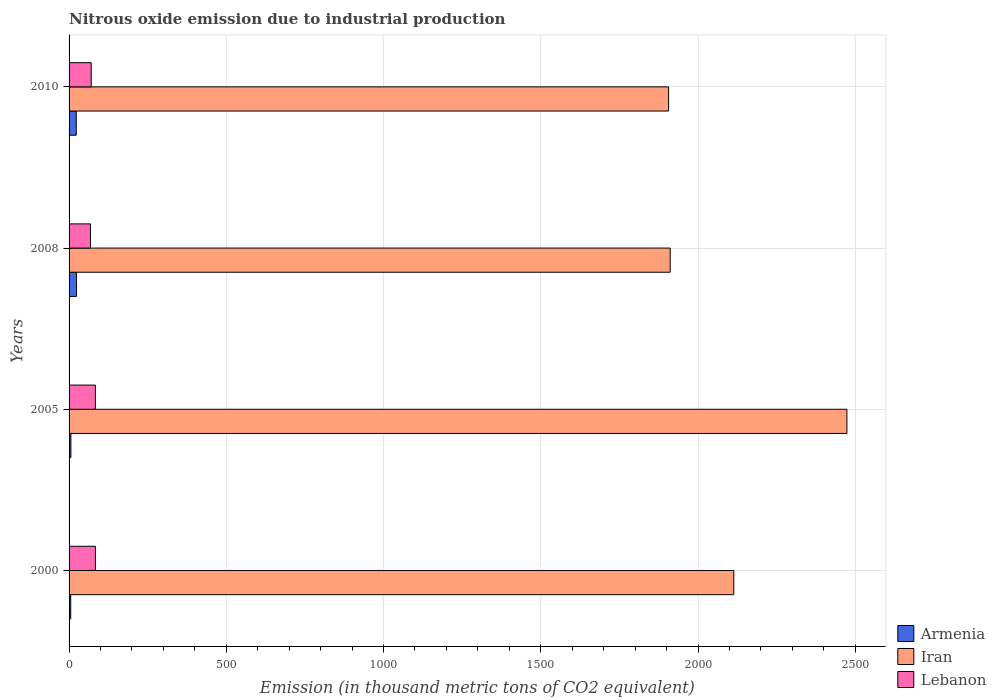Are the number of bars on each tick of the Y-axis equal?
Give a very brief answer. Yes. How many bars are there on the 1st tick from the bottom?
Offer a terse response. 3. What is the amount of nitrous oxide emitted in Armenia in 2010?
Keep it short and to the point. 22.8. Across all years, what is the maximum amount of nitrous oxide emitted in Iran?
Give a very brief answer. 2473.5. In which year was the amount of nitrous oxide emitted in Armenia maximum?
Ensure brevity in your answer.  2008. In which year was the amount of nitrous oxide emitted in Armenia minimum?
Offer a terse response. 2000. What is the total amount of nitrous oxide emitted in Armenia in the graph?
Provide a succinct answer. 57.5. What is the difference between the amount of nitrous oxide emitted in Armenia in 2000 and that in 2010?
Your answer should be very brief. -17.6. What is the difference between the amount of nitrous oxide emitted in Lebanon in 2010 and the amount of nitrous oxide emitted in Armenia in 2005?
Your answer should be very brief. 64.6. What is the average amount of nitrous oxide emitted in Lebanon per year?
Your answer should be very brief. 76.47. In the year 2000, what is the difference between the amount of nitrous oxide emitted in Armenia and amount of nitrous oxide emitted in Lebanon?
Your response must be concise. -78.6. What is the ratio of the amount of nitrous oxide emitted in Lebanon in 2000 to that in 2008?
Your answer should be compact. 1.23. Is the difference between the amount of nitrous oxide emitted in Armenia in 2005 and 2010 greater than the difference between the amount of nitrous oxide emitted in Lebanon in 2005 and 2010?
Provide a short and direct response. No. What is the difference between the highest and the second highest amount of nitrous oxide emitted in Armenia?
Your answer should be compact. 0.9. What is the difference between the highest and the lowest amount of nitrous oxide emitted in Lebanon?
Ensure brevity in your answer.  15.8. In how many years, is the amount of nitrous oxide emitted in Iran greater than the average amount of nitrous oxide emitted in Iran taken over all years?
Offer a very short reply. 2. What does the 2nd bar from the top in 2005 represents?
Provide a short and direct response. Iran. What does the 3rd bar from the bottom in 2010 represents?
Offer a very short reply. Lebanon. Is it the case that in every year, the sum of the amount of nitrous oxide emitted in Lebanon and amount of nitrous oxide emitted in Iran is greater than the amount of nitrous oxide emitted in Armenia?
Offer a terse response. Yes. How many bars are there?
Offer a terse response. 12. How many years are there in the graph?
Your answer should be compact. 4. What is the difference between two consecutive major ticks on the X-axis?
Make the answer very short. 500. Are the values on the major ticks of X-axis written in scientific E-notation?
Provide a succinct answer. No. Does the graph contain any zero values?
Make the answer very short. No. How many legend labels are there?
Your answer should be very brief. 3. How are the legend labels stacked?
Your answer should be very brief. Vertical. What is the title of the graph?
Offer a very short reply. Nitrous oxide emission due to industrial production. What is the label or title of the X-axis?
Provide a short and direct response. Emission (in thousand metric tons of CO2 equivalent). What is the label or title of the Y-axis?
Make the answer very short. Years. What is the Emission (in thousand metric tons of CO2 equivalent) of Iran in 2000?
Give a very brief answer. 2113.8. What is the Emission (in thousand metric tons of CO2 equivalent) of Lebanon in 2000?
Offer a terse response. 83.8. What is the Emission (in thousand metric tons of CO2 equivalent) of Iran in 2005?
Make the answer very short. 2473.5. What is the Emission (in thousand metric tons of CO2 equivalent) of Lebanon in 2005?
Offer a very short reply. 83.7. What is the Emission (in thousand metric tons of CO2 equivalent) in Armenia in 2008?
Make the answer very short. 23.7. What is the Emission (in thousand metric tons of CO2 equivalent) in Iran in 2008?
Your answer should be compact. 1911.5. What is the Emission (in thousand metric tons of CO2 equivalent) in Lebanon in 2008?
Your answer should be compact. 68. What is the Emission (in thousand metric tons of CO2 equivalent) in Armenia in 2010?
Make the answer very short. 22.8. What is the Emission (in thousand metric tons of CO2 equivalent) of Iran in 2010?
Keep it short and to the point. 1906.5. What is the Emission (in thousand metric tons of CO2 equivalent) of Lebanon in 2010?
Your answer should be very brief. 70.4. Across all years, what is the maximum Emission (in thousand metric tons of CO2 equivalent) of Armenia?
Keep it short and to the point. 23.7. Across all years, what is the maximum Emission (in thousand metric tons of CO2 equivalent) of Iran?
Provide a short and direct response. 2473.5. Across all years, what is the maximum Emission (in thousand metric tons of CO2 equivalent) in Lebanon?
Make the answer very short. 83.8. Across all years, what is the minimum Emission (in thousand metric tons of CO2 equivalent) in Armenia?
Keep it short and to the point. 5.2. Across all years, what is the minimum Emission (in thousand metric tons of CO2 equivalent) in Iran?
Provide a short and direct response. 1906.5. Across all years, what is the minimum Emission (in thousand metric tons of CO2 equivalent) of Lebanon?
Give a very brief answer. 68. What is the total Emission (in thousand metric tons of CO2 equivalent) of Armenia in the graph?
Offer a terse response. 57.5. What is the total Emission (in thousand metric tons of CO2 equivalent) in Iran in the graph?
Your answer should be very brief. 8405.3. What is the total Emission (in thousand metric tons of CO2 equivalent) of Lebanon in the graph?
Your answer should be very brief. 305.9. What is the difference between the Emission (in thousand metric tons of CO2 equivalent) of Armenia in 2000 and that in 2005?
Provide a succinct answer. -0.6. What is the difference between the Emission (in thousand metric tons of CO2 equivalent) in Iran in 2000 and that in 2005?
Offer a terse response. -359.7. What is the difference between the Emission (in thousand metric tons of CO2 equivalent) of Armenia in 2000 and that in 2008?
Provide a succinct answer. -18.5. What is the difference between the Emission (in thousand metric tons of CO2 equivalent) of Iran in 2000 and that in 2008?
Your answer should be compact. 202.3. What is the difference between the Emission (in thousand metric tons of CO2 equivalent) of Lebanon in 2000 and that in 2008?
Your answer should be very brief. 15.8. What is the difference between the Emission (in thousand metric tons of CO2 equivalent) of Armenia in 2000 and that in 2010?
Give a very brief answer. -17.6. What is the difference between the Emission (in thousand metric tons of CO2 equivalent) in Iran in 2000 and that in 2010?
Make the answer very short. 207.3. What is the difference between the Emission (in thousand metric tons of CO2 equivalent) of Armenia in 2005 and that in 2008?
Keep it short and to the point. -17.9. What is the difference between the Emission (in thousand metric tons of CO2 equivalent) in Iran in 2005 and that in 2008?
Offer a terse response. 562. What is the difference between the Emission (in thousand metric tons of CO2 equivalent) in Iran in 2005 and that in 2010?
Keep it short and to the point. 567. What is the difference between the Emission (in thousand metric tons of CO2 equivalent) in Lebanon in 2005 and that in 2010?
Ensure brevity in your answer.  13.3. What is the difference between the Emission (in thousand metric tons of CO2 equivalent) in Armenia in 2008 and that in 2010?
Make the answer very short. 0.9. What is the difference between the Emission (in thousand metric tons of CO2 equivalent) of Armenia in 2000 and the Emission (in thousand metric tons of CO2 equivalent) of Iran in 2005?
Make the answer very short. -2468.3. What is the difference between the Emission (in thousand metric tons of CO2 equivalent) of Armenia in 2000 and the Emission (in thousand metric tons of CO2 equivalent) of Lebanon in 2005?
Ensure brevity in your answer.  -78.5. What is the difference between the Emission (in thousand metric tons of CO2 equivalent) of Iran in 2000 and the Emission (in thousand metric tons of CO2 equivalent) of Lebanon in 2005?
Provide a short and direct response. 2030.1. What is the difference between the Emission (in thousand metric tons of CO2 equivalent) in Armenia in 2000 and the Emission (in thousand metric tons of CO2 equivalent) in Iran in 2008?
Your answer should be very brief. -1906.3. What is the difference between the Emission (in thousand metric tons of CO2 equivalent) in Armenia in 2000 and the Emission (in thousand metric tons of CO2 equivalent) in Lebanon in 2008?
Provide a short and direct response. -62.8. What is the difference between the Emission (in thousand metric tons of CO2 equivalent) of Iran in 2000 and the Emission (in thousand metric tons of CO2 equivalent) of Lebanon in 2008?
Ensure brevity in your answer.  2045.8. What is the difference between the Emission (in thousand metric tons of CO2 equivalent) of Armenia in 2000 and the Emission (in thousand metric tons of CO2 equivalent) of Iran in 2010?
Make the answer very short. -1901.3. What is the difference between the Emission (in thousand metric tons of CO2 equivalent) of Armenia in 2000 and the Emission (in thousand metric tons of CO2 equivalent) of Lebanon in 2010?
Keep it short and to the point. -65.2. What is the difference between the Emission (in thousand metric tons of CO2 equivalent) in Iran in 2000 and the Emission (in thousand metric tons of CO2 equivalent) in Lebanon in 2010?
Offer a terse response. 2043.4. What is the difference between the Emission (in thousand metric tons of CO2 equivalent) of Armenia in 2005 and the Emission (in thousand metric tons of CO2 equivalent) of Iran in 2008?
Your response must be concise. -1905.7. What is the difference between the Emission (in thousand metric tons of CO2 equivalent) of Armenia in 2005 and the Emission (in thousand metric tons of CO2 equivalent) of Lebanon in 2008?
Offer a terse response. -62.2. What is the difference between the Emission (in thousand metric tons of CO2 equivalent) in Iran in 2005 and the Emission (in thousand metric tons of CO2 equivalent) in Lebanon in 2008?
Give a very brief answer. 2405.5. What is the difference between the Emission (in thousand metric tons of CO2 equivalent) of Armenia in 2005 and the Emission (in thousand metric tons of CO2 equivalent) of Iran in 2010?
Your response must be concise. -1900.7. What is the difference between the Emission (in thousand metric tons of CO2 equivalent) in Armenia in 2005 and the Emission (in thousand metric tons of CO2 equivalent) in Lebanon in 2010?
Offer a very short reply. -64.6. What is the difference between the Emission (in thousand metric tons of CO2 equivalent) of Iran in 2005 and the Emission (in thousand metric tons of CO2 equivalent) of Lebanon in 2010?
Make the answer very short. 2403.1. What is the difference between the Emission (in thousand metric tons of CO2 equivalent) in Armenia in 2008 and the Emission (in thousand metric tons of CO2 equivalent) in Iran in 2010?
Provide a short and direct response. -1882.8. What is the difference between the Emission (in thousand metric tons of CO2 equivalent) of Armenia in 2008 and the Emission (in thousand metric tons of CO2 equivalent) of Lebanon in 2010?
Provide a short and direct response. -46.7. What is the difference between the Emission (in thousand metric tons of CO2 equivalent) of Iran in 2008 and the Emission (in thousand metric tons of CO2 equivalent) of Lebanon in 2010?
Your response must be concise. 1841.1. What is the average Emission (in thousand metric tons of CO2 equivalent) of Armenia per year?
Your response must be concise. 14.38. What is the average Emission (in thousand metric tons of CO2 equivalent) of Iran per year?
Provide a short and direct response. 2101.32. What is the average Emission (in thousand metric tons of CO2 equivalent) in Lebanon per year?
Offer a terse response. 76.47. In the year 2000, what is the difference between the Emission (in thousand metric tons of CO2 equivalent) in Armenia and Emission (in thousand metric tons of CO2 equivalent) in Iran?
Provide a short and direct response. -2108.6. In the year 2000, what is the difference between the Emission (in thousand metric tons of CO2 equivalent) of Armenia and Emission (in thousand metric tons of CO2 equivalent) of Lebanon?
Provide a short and direct response. -78.6. In the year 2000, what is the difference between the Emission (in thousand metric tons of CO2 equivalent) in Iran and Emission (in thousand metric tons of CO2 equivalent) in Lebanon?
Your answer should be compact. 2030. In the year 2005, what is the difference between the Emission (in thousand metric tons of CO2 equivalent) of Armenia and Emission (in thousand metric tons of CO2 equivalent) of Iran?
Keep it short and to the point. -2467.7. In the year 2005, what is the difference between the Emission (in thousand metric tons of CO2 equivalent) of Armenia and Emission (in thousand metric tons of CO2 equivalent) of Lebanon?
Make the answer very short. -77.9. In the year 2005, what is the difference between the Emission (in thousand metric tons of CO2 equivalent) in Iran and Emission (in thousand metric tons of CO2 equivalent) in Lebanon?
Your response must be concise. 2389.8. In the year 2008, what is the difference between the Emission (in thousand metric tons of CO2 equivalent) in Armenia and Emission (in thousand metric tons of CO2 equivalent) in Iran?
Give a very brief answer. -1887.8. In the year 2008, what is the difference between the Emission (in thousand metric tons of CO2 equivalent) in Armenia and Emission (in thousand metric tons of CO2 equivalent) in Lebanon?
Offer a terse response. -44.3. In the year 2008, what is the difference between the Emission (in thousand metric tons of CO2 equivalent) of Iran and Emission (in thousand metric tons of CO2 equivalent) of Lebanon?
Provide a short and direct response. 1843.5. In the year 2010, what is the difference between the Emission (in thousand metric tons of CO2 equivalent) of Armenia and Emission (in thousand metric tons of CO2 equivalent) of Iran?
Your answer should be compact. -1883.7. In the year 2010, what is the difference between the Emission (in thousand metric tons of CO2 equivalent) of Armenia and Emission (in thousand metric tons of CO2 equivalent) of Lebanon?
Provide a short and direct response. -47.6. In the year 2010, what is the difference between the Emission (in thousand metric tons of CO2 equivalent) in Iran and Emission (in thousand metric tons of CO2 equivalent) in Lebanon?
Make the answer very short. 1836.1. What is the ratio of the Emission (in thousand metric tons of CO2 equivalent) of Armenia in 2000 to that in 2005?
Provide a short and direct response. 0.9. What is the ratio of the Emission (in thousand metric tons of CO2 equivalent) in Iran in 2000 to that in 2005?
Provide a succinct answer. 0.85. What is the ratio of the Emission (in thousand metric tons of CO2 equivalent) of Lebanon in 2000 to that in 2005?
Provide a short and direct response. 1. What is the ratio of the Emission (in thousand metric tons of CO2 equivalent) of Armenia in 2000 to that in 2008?
Keep it short and to the point. 0.22. What is the ratio of the Emission (in thousand metric tons of CO2 equivalent) in Iran in 2000 to that in 2008?
Offer a terse response. 1.11. What is the ratio of the Emission (in thousand metric tons of CO2 equivalent) of Lebanon in 2000 to that in 2008?
Offer a very short reply. 1.23. What is the ratio of the Emission (in thousand metric tons of CO2 equivalent) in Armenia in 2000 to that in 2010?
Give a very brief answer. 0.23. What is the ratio of the Emission (in thousand metric tons of CO2 equivalent) of Iran in 2000 to that in 2010?
Ensure brevity in your answer.  1.11. What is the ratio of the Emission (in thousand metric tons of CO2 equivalent) in Lebanon in 2000 to that in 2010?
Give a very brief answer. 1.19. What is the ratio of the Emission (in thousand metric tons of CO2 equivalent) of Armenia in 2005 to that in 2008?
Provide a short and direct response. 0.24. What is the ratio of the Emission (in thousand metric tons of CO2 equivalent) of Iran in 2005 to that in 2008?
Your answer should be compact. 1.29. What is the ratio of the Emission (in thousand metric tons of CO2 equivalent) of Lebanon in 2005 to that in 2008?
Your response must be concise. 1.23. What is the ratio of the Emission (in thousand metric tons of CO2 equivalent) of Armenia in 2005 to that in 2010?
Provide a succinct answer. 0.25. What is the ratio of the Emission (in thousand metric tons of CO2 equivalent) in Iran in 2005 to that in 2010?
Ensure brevity in your answer.  1.3. What is the ratio of the Emission (in thousand metric tons of CO2 equivalent) of Lebanon in 2005 to that in 2010?
Make the answer very short. 1.19. What is the ratio of the Emission (in thousand metric tons of CO2 equivalent) in Armenia in 2008 to that in 2010?
Keep it short and to the point. 1.04. What is the ratio of the Emission (in thousand metric tons of CO2 equivalent) of Lebanon in 2008 to that in 2010?
Provide a short and direct response. 0.97. What is the difference between the highest and the second highest Emission (in thousand metric tons of CO2 equivalent) in Iran?
Your answer should be very brief. 359.7. What is the difference between the highest and the second highest Emission (in thousand metric tons of CO2 equivalent) in Lebanon?
Your answer should be compact. 0.1. What is the difference between the highest and the lowest Emission (in thousand metric tons of CO2 equivalent) of Iran?
Give a very brief answer. 567. 